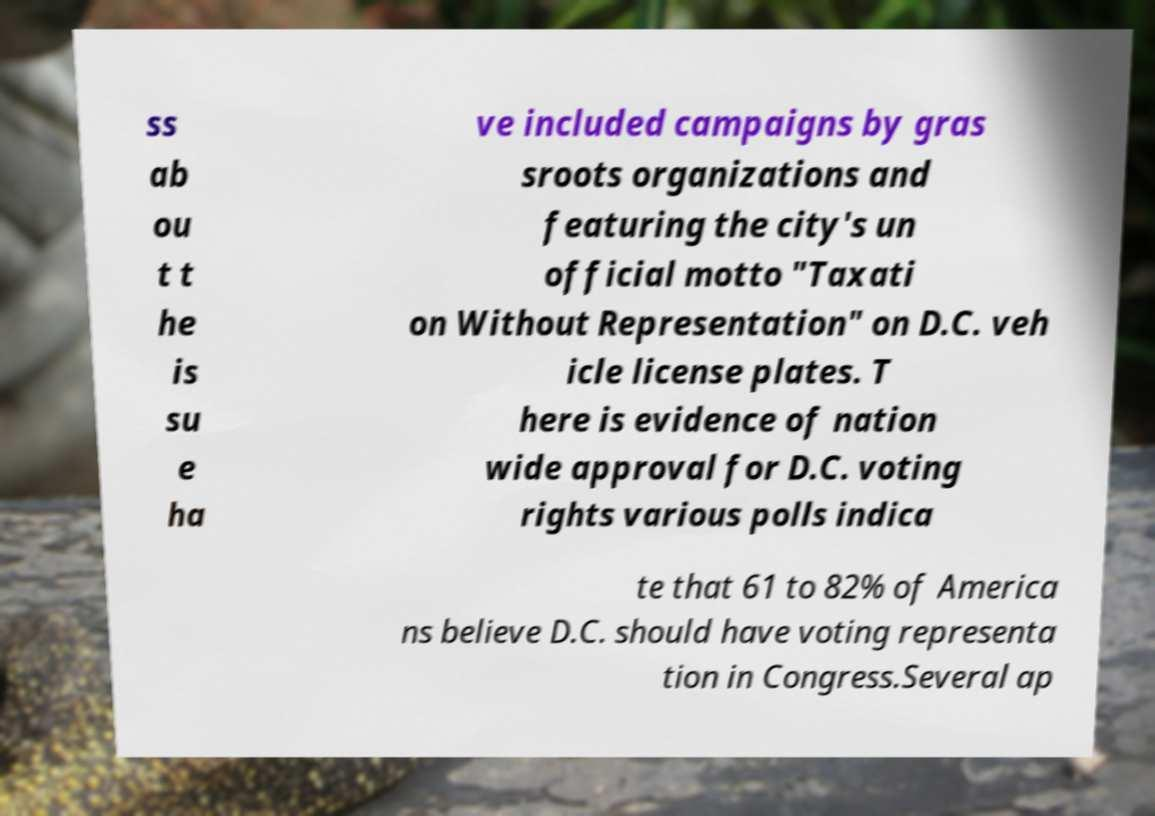Could you assist in decoding the text presented in this image and type it out clearly? ss ab ou t t he is su e ha ve included campaigns by gras sroots organizations and featuring the city's un official motto "Taxati on Without Representation" on D.C. veh icle license plates. T here is evidence of nation wide approval for D.C. voting rights various polls indica te that 61 to 82% of America ns believe D.C. should have voting representa tion in Congress.Several ap 